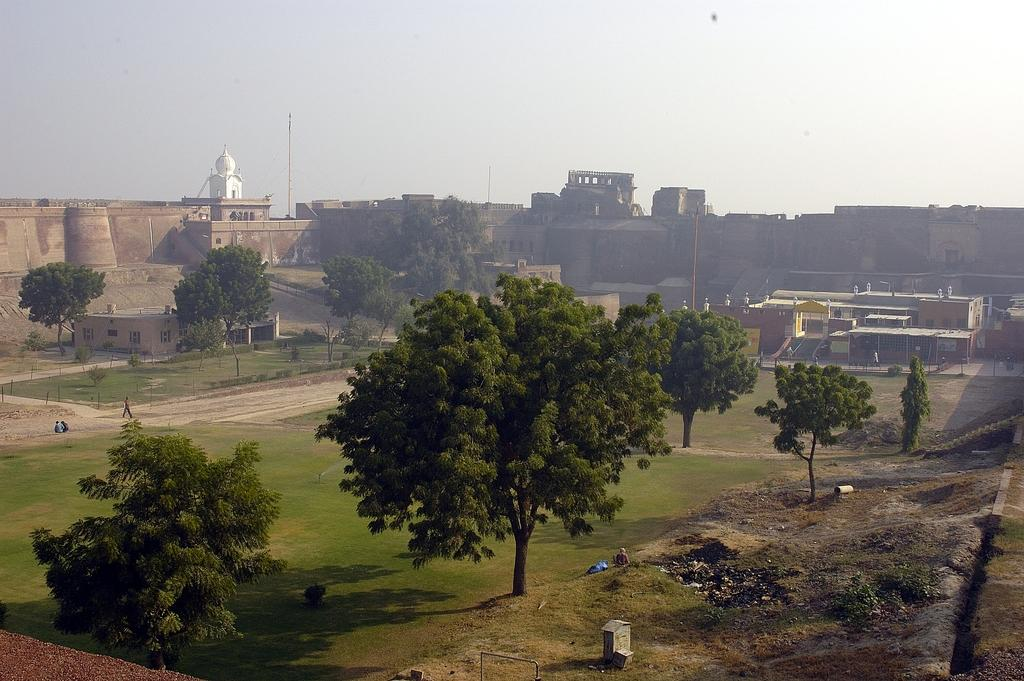What type of vegetation is visible in the front of the image? There are trees in the front of the image. What type of structures can be seen in the background of the image? There are buildings in the background of the image. Are there any trees visible in the background of the image? Yes, there are trees in the background of the image. What type of ground cover is present in the center of the image? There is grass on the ground in the center of the image. What type of toys can be seen scattered on the grass in the image? There are no toys present in the image; it features trees, buildings, and grass. How many pages of a book are visible in the image? There are no pages or books present in the image. 